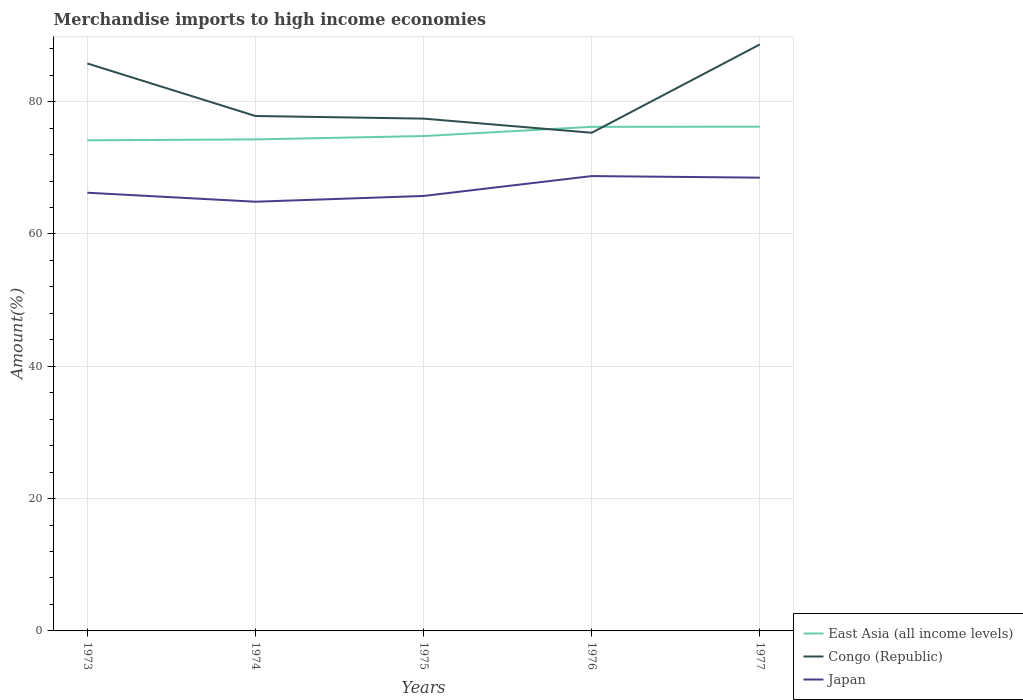How many different coloured lines are there?
Make the answer very short. 3. Is the number of lines equal to the number of legend labels?
Your answer should be compact. Yes. Across all years, what is the maximum percentage of amount earned from merchandise imports in Japan?
Offer a terse response. 64.87. In which year was the percentage of amount earned from merchandise imports in Japan maximum?
Your answer should be compact. 1974. What is the total percentage of amount earned from merchandise imports in Congo (Republic) in the graph?
Your answer should be compact. 0.4. What is the difference between the highest and the second highest percentage of amount earned from merchandise imports in East Asia (all income levels)?
Ensure brevity in your answer.  2.06. What is the difference between the highest and the lowest percentage of amount earned from merchandise imports in Congo (Republic)?
Your answer should be compact. 2. How many lines are there?
Ensure brevity in your answer.  3. Does the graph contain any zero values?
Provide a short and direct response. No. Where does the legend appear in the graph?
Give a very brief answer. Bottom right. How many legend labels are there?
Make the answer very short. 3. What is the title of the graph?
Ensure brevity in your answer.  Merchandise imports to high income economies. Does "Pakistan" appear as one of the legend labels in the graph?
Make the answer very short. No. What is the label or title of the Y-axis?
Give a very brief answer. Amount(%). What is the Amount(%) in East Asia (all income levels) in 1973?
Your answer should be very brief. 74.15. What is the Amount(%) of Congo (Republic) in 1973?
Provide a succinct answer. 85.77. What is the Amount(%) in Japan in 1973?
Your answer should be compact. 66.23. What is the Amount(%) in East Asia (all income levels) in 1974?
Keep it short and to the point. 74.29. What is the Amount(%) of Congo (Republic) in 1974?
Ensure brevity in your answer.  77.83. What is the Amount(%) of Japan in 1974?
Your answer should be very brief. 64.87. What is the Amount(%) of East Asia (all income levels) in 1975?
Your answer should be compact. 74.8. What is the Amount(%) of Congo (Republic) in 1975?
Make the answer very short. 77.43. What is the Amount(%) in Japan in 1975?
Keep it short and to the point. 65.74. What is the Amount(%) in East Asia (all income levels) in 1976?
Give a very brief answer. 76.19. What is the Amount(%) of Congo (Republic) in 1976?
Make the answer very short. 75.3. What is the Amount(%) in Japan in 1976?
Give a very brief answer. 68.75. What is the Amount(%) of East Asia (all income levels) in 1977?
Your answer should be compact. 76.21. What is the Amount(%) of Congo (Republic) in 1977?
Provide a succinct answer. 88.64. What is the Amount(%) in Japan in 1977?
Offer a very short reply. 68.51. Across all years, what is the maximum Amount(%) of East Asia (all income levels)?
Give a very brief answer. 76.21. Across all years, what is the maximum Amount(%) in Congo (Republic)?
Give a very brief answer. 88.64. Across all years, what is the maximum Amount(%) of Japan?
Your answer should be very brief. 68.75. Across all years, what is the minimum Amount(%) in East Asia (all income levels)?
Your answer should be compact. 74.15. Across all years, what is the minimum Amount(%) in Congo (Republic)?
Make the answer very short. 75.3. Across all years, what is the minimum Amount(%) in Japan?
Keep it short and to the point. 64.87. What is the total Amount(%) of East Asia (all income levels) in the graph?
Keep it short and to the point. 375.65. What is the total Amount(%) of Congo (Republic) in the graph?
Give a very brief answer. 404.97. What is the total Amount(%) of Japan in the graph?
Keep it short and to the point. 334.11. What is the difference between the Amount(%) in East Asia (all income levels) in 1973 and that in 1974?
Your answer should be very brief. -0.14. What is the difference between the Amount(%) of Congo (Republic) in 1973 and that in 1974?
Offer a very short reply. 7.94. What is the difference between the Amount(%) in Japan in 1973 and that in 1974?
Offer a very short reply. 1.36. What is the difference between the Amount(%) in East Asia (all income levels) in 1973 and that in 1975?
Provide a succinct answer. -0.64. What is the difference between the Amount(%) in Congo (Republic) in 1973 and that in 1975?
Offer a very short reply. 8.34. What is the difference between the Amount(%) of Japan in 1973 and that in 1975?
Your answer should be compact. 0.49. What is the difference between the Amount(%) in East Asia (all income levels) in 1973 and that in 1976?
Your answer should be very brief. -2.04. What is the difference between the Amount(%) in Congo (Republic) in 1973 and that in 1976?
Keep it short and to the point. 10.47. What is the difference between the Amount(%) of Japan in 1973 and that in 1976?
Provide a succinct answer. -2.52. What is the difference between the Amount(%) in East Asia (all income levels) in 1973 and that in 1977?
Your answer should be compact. -2.06. What is the difference between the Amount(%) of Congo (Republic) in 1973 and that in 1977?
Provide a short and direct response. -2.88. What is the difference between the Amount(%) of Japan in 1973 and that in 1977?
Give a very brief answer. -2.28. What is the difference between the Amount(%) of East Asia (all income levels) in 1974 and that in 1975?
Provide a short and direct response. -0.51. What is the difference between the Amount(%) of Congo (Republic) in 1974 and that in 1975?
Give a very brief answer. 0.4. What is the difference between the Amount(%) in Japan in 1974 and that in 1975?
Keep it short and to the point. -0.87. What is the difference between the Amount(%) in East Asia (all income levels) in 1974 and that in 1976?
Offer a terse response. -1.9. What is the difference between the Amount(%) in Congo (Republic) in 1974 and that in 1976?
Make the answer very short. 2.53. What is the difference between the Amount(%) in Japan in 1974 and that in 1976?
Provide a short and direct response. -3.88. What is the difference between the Amount(%) in East Asia (all income levels) in 1974 and that in 1977?
Your response must be concise. -1.92. What is the difference between the Amount(%) in Congo (Republic) in 1974 and that in 1977?
Offer a terse response. -10.82. What is the difference between the Amount(%) in Japan in 1974 and that in 1977?
Ensure brevity in your answer.  -3.64. What is the difference between the Amount(%) in East Asia (all income levels) in 1975 and that in 1976?
Your response must be concise. -1.39. What is the difference between the Amount(%) of Congo (Republic) in 1975 and that in 1976?
Give a very brief answer. 2.14. What is the difference between the Amount(%) of Japan in 1975 and that in 1976?
Make the answer very short. -3. What is the difference between the Amount(%) of East Asia (all income levels) in 1975 and that in 1977?
Your answer should be compact. -1.42. What is the difference between the Amount(%) in Congo (Republic) in 1975 and that in 1977?
Make the answer very short. -11.21. What is the difference between the Amount(%) in Japan in 1975 and that in 1977?
Keep it short and to the point. -2.77. What is the difference between the Amount(%) in East Asia (all income levels) in 1976 and that in 1977?
Give a very brief answer. -0.02. What is the difference between the Amount(%) in Congo (Republic) in 1976 and that in 1977?
Make the answer very short. -13.35. What is the difference between the Amount(%) of Japan in 1976 and that in 1977?
Offer a terse response. 0.24. What is the difference between the Amount(%) in East Asia (all income levels) in 1973 and the Amount(%) in Congo (Republic) in 1974?
Offer a terse response. -3.67. What is the difference between the Amount(%) of East Asia (all income levels) in 1973 and the Amount(%) of Japan in 1974?
Offer a very short reply. 9.28. What is the difference between the Amount(%) of Congo (Republic) in 1973 and the Amount(%) of Japan in 1974?
Your response must be concise. 20.89. What is the difference between the Amount(%) in East Asia (all income levels) in 1973 and the Amount(%) in Congo (Republic) in 1975?
Offer a terse response. -3.28. What is the difference between the Amount(%) of East Asia (all income levels) in 1973 and the Amount(%) of Japan in 1975?
Ensure brevity in your answer.  8.41. What is the difference between the Amount(%) in Congo (Republic) in 1973 and the Amount(%) in Japan in 1975?
Your answer should be very brief. 20.02. What is the difference between the Amount(%) of East Asia (all income levels) in 1973 and the Amount(%) of Congo (Republic) in 1976?
Provide a succinct answer. -1.14. What is the difference between the Amount(%) in East Asia (all income levels) in 1973 and the Amount(%) in Japan in 1976?
Keep it short and to the point. 5.4. What is the difference between the Amount(%) of Congo (Republic) in 1973 and the Amount(%) of Japan in 1976?
Keep it short and to the point. 17.02. What is the difference between the Amount(%) of East Asia (all income levels) in 1973 and the Amount(%) of Congo (Republic) in 1977?
Provide a succinct answer. -14.49. What is the difference between the Amount(%) of East Asia (all income levels) in 1973 and the Amount(%) of Japan in 1977?
Ensure brevity in your answer.  5.64. What is the difference between the Amount(%) of Congo (Republic) in 1973 and the Amount(%) of Japan in 1977?
Your response must be concise. 17.26. What is the difference between the Amount(%) in East Asia (all income levels) in 1974 and the Amount(%) in Congo (Republic) in 1975?
Make the answer very short. -3.14. What is the difference between the Amount(%) of East Asia (all income levels) in 1974 and the Amount(%) of Japan in 1975?
Your answer should be compact. 8.55. What is the difference between the Amount(%) of Congo (Republic) in 1974 and the Amount(%) of Japan in 1975?
Your response must be concise. 12.08. What is the difference between the Amount(%) of East Asia (all income levels) in 1974 and the Amount(%) of Congo (Republic) in 1976?
Ensure brevity in your answer.  -1.01. What is the difference between the Amount(%) of East Asia (all income levels) in 1974 and the Amount(%) of Japan in 1976?
Offer a very short reply. 5.54. What is the difference between the Amount(%) of Congo (Republic) in 1974 and the Amount(%) of Japan in 1976?
Your response must be concise. 9.08. What is the difference between the Amount(%) of East Asia (all income levels) in 1974 and the Amount(%) of Congo (Republic) in 1977?
Provide a short and direct response. -14.35. What is the difference between the Amount(%) in East Asia (all income levels) in 1974 and the Amount(%) in Japan in 1977?
Your answer should be very brief. 5.78. What is the difference between the Amount(%) of Congo (Republic) in 1974 and the Amount(%) of Japan in 1977?
Your response must be concise. 9.32. What is the difference between the Amount(%) in East Asia (all income levels) in 1975 and the Amount(%) in Congo (Republic) in 1976?
Provide a succinct answer. -0.5. What is the difference between the Amount(%) in East Asia (all income levels) in 1975 and the Amount(%) in Japan in 1976?
Your answer should be compact. 6.05. What is the difference between the Amount(%) in Congo (Republic) in 1975 and the Amount(%) in Japan in 1976?
Your answer should be very brief. 8.68. What is the difference between the Amount(%) of East Asia (all income levels) in 1975 and the Amount(%) of Congo (Republic) in 1977?
Your answer should be very brief. -13.85. What is the difference between the Amount(%) in East Asia (all income levels) in 1975 and the Amount(%) in Japan in 1977?
Your answer should be very brief. 6.29. What is the difference between the Amount(%) of Congo (Republic) in 1975 and the Amount(%) of Japan in 1977?
Offer a terse response. 8.92. What is the difference between the Amount(%) in East Asia (all income levels) in 1976 and the Amount(%) in Congo (Republic) in 1977?
Give a very brief answer. -12.45. What is the difference between the Amount(%) in East Asia (all income levels) in 1976 and the Amount(%) in Japan in 1977?
Offer a terse response. 7.68. What is the difference between the Amount(%) of Congo (Republic) in 1976 and the Amount(%) of Japan in 1977?
Provide a succinct answer. 6.79. What is the average Amount(%) in East Asia (all income levels) per year?
Give a very brief answer. 75.13. What is the average Amount(%) in Congo (Republic) per year?
Keep it short and to the point. 80.99. What is the average Amount(%) in Japan per year?
Your response must be concise. 66.82. In the year 1973, what is the difference between the Amount(%) of East Asia (all income levels) and Amount(%) of Congo (Republic)?
Your response must be concise. -11.61. In the year 1973, what is the difference between the Amount(%) of East Asia (all income levels) and Amount(%) of Japan?
Your response must be concise. 7.92. In the year 1973, what is the difference between the Amount(%) of Congo (Republic) and Amount(%) of Japan?
Provide a succinct answer. 19.53. In the year 1974, what is the difference between the Amount(%) of East Asia (all income levels) and Amount(%) of Congo (Republic)?
Your response must be concise. -3.54. In the year 1974, what is the difference between the Amount(%) of East Asia (all income levels) and Amount(%) of Japan?
Offer a terse response. 9.42. In the year 1974, what is the difference between the Amount(%) in Congo (Republic) and Amount(%) in Japan?
Give a very brief answer. 12.96. In the year 1975, what is the difference between the Amount(%) of East Asia (all income levels) and Amount(%) of Congo (Republic)?
Your answer should be compact. -2.64. In the year 1975, what is the difference between the Amount(%) of East Asia (all income levels) and Amount(%) of Japan?
Ensure brevity in your answer.  9.05. In the year 1975, what is the difference between the Amount(%) of Congo (Republic) and Amount(%) of Japan?
Keep it short and to the point. 11.69. In the year 1976, what is the difference between the Amount(%) of East Asia (all income levels) and Amount(%) of Congo (Republic)?
Your response must be concise. 0.9. In the year 1976, what is the difference between the Amount(%) in East Asia (all income levels) and Amount(%) in Japan?
Ensure brevity in your answer.  7.44. In the year 1976, what is the difference between the Amount(%) of Congo (Republic) and Amount(%) of Japan?
Keep it short and to the point. 6.55. In the year 1977, what is the difference between the Amount(%) in East Asia (all income levels) and Amount(%) in Congo (Republic)?
Provide a short and direct response. -12.43. In the year 1977, what is the difference between the Amount(%) in East Asia (all income levels) and Amount(%) in Japan?
Provide a succinct answer. 7.7. In the year 1977, what is the difference between the Amount(%) of Congo (Republic) and Amount(%) of Japan?
Make the answer very short. 20.13. What is the ratio of the Amount(%) in East Asia (all income levels) in 1973 to that in 1974?
Offer a very short reply. 1. What is the ratio of the Amount(%) in Congo (Republic) in 1973 to that in 1974?
Keep it short and to the point. 1.1. What is the ratio of the Amount(%) of Congo (Republic) in 1973 to that in 1975?
Give a very brief answer. 1.11. What is the ratio of the Amount(%) in Japan in 1973 to that in 1975?
Provide a short and direct response. 1.01. What is the ratio of the Amount(%) in East Asia (all income levels) in 1973 to that in 1976?
Make the answer very short. 0.97. What is the ratio of the Amount(%) of Congo (Republic) in 1973 to that in 1976?
Keep it short and to the point. 1.14. What is the ratio of the Amount(%) of Japan in 1973 to that in 1976?
Give a very brief answer. 0.96. What is the ratio of the Amount(%) of Congo (Republic) in 1973 to that in 1977?
Give a very brief answer. 0.97. What is the ratio of the Amount(%) of Japan in 1973 to that in 1977?
Your response must be concise. 0.97. What is the ratio of the Amount(%) of East Asia (all income levels) in 1974 to that in 1975?
Make the answer very short. 0.99. What is the ratio of the Amount(%) in Congo (Republic) in 1974 to that in 1975?
Your answer should be compact. 1.01. What is the ratio of the Amount(%) of Japan in 1974 to that in 1975?
Provide a succinct answer. 0.99. What is the ratio of the Amount(%) in Congo (Republic) in 1974 to that in 1976?
Keep it short and to the point. 1.03. What is the ratio of the Amount(%) in Japan in 1974 to that in 1976?
Your response must be concise. 0.94. What is the ratio of the Amount(%) in East Asia (all income levels) in 1974 to that in 1977?
Make the answer very short. 0.97. What is the ratio of the Amount(%) in Congo (Republic) in 1974 to that in 1977?
Ensure brevity in your answer.  0.88. What is the ratio of the Amount(%) in Japan in 1974 to that in 1977?
Your response must be concise. 0.95. What is the ratio of the Amount(%) in East Asia (all income levels) in 1975 to that in 1976?
Give a very brief answer. 0.98. What is the ratio of the Amount(%) of Congo (Republic) in 1975 to that in 1976?
Provide a succinct answer. 1.03. What is the ratio of the Amount(%) of Japan in 1975 to that in 1976?
Provide a short and direct response. 0.96. What is the ratio of the Amount(%) in East Asia (all income levels) in 1975 to that in 1977?
Provide a short and direct response. 0.98. What is the ratio of the Amount(%) in Congo (Republic) in 1975 to that in 1977?
Ensure brevity in your answer.  0.87. What is the ratio of the Amount(%) of Japan in 1975 to that in 1977?
Your response must be concise. 0.96. What is the ratio of the Amount(%) of East Asia (all income levels) in 1976 to that in 1977?
Offer a terse response. 1. What is the ratio of the Amount(%) in Congo (Republic) in 1976 to that in 1977?
Your answer should be compact. 0.85. What is the ratio of the Amount(%) of Japan in 1976 to that in 1977?
Your answer should be very brief. 1. What is the difference between the highest and the second highest Amount(%) in East Asia (all income levels)?
Offer a terse response. 0.02. What is the difference between the highest and the second highest Amount(%) in Congo (Republic)?
Your answer should be very brief. 2.88. What is the difference between the highest and the second highest Amount(%) in Japan?
Offer a very short reply. 0.24. What is the difference between the highest and the lowest Amount(%) of East Asia (all income levels)?
Make the answer very short. 2.06. What is the difference between the highest and the lowest Amount(%) of Congo (Republic)?
Your answer should be compact. 13.35. What is the difference between the highest and the lowest Amount(%) in Japan?
Give a very brief answer. 3.88. 